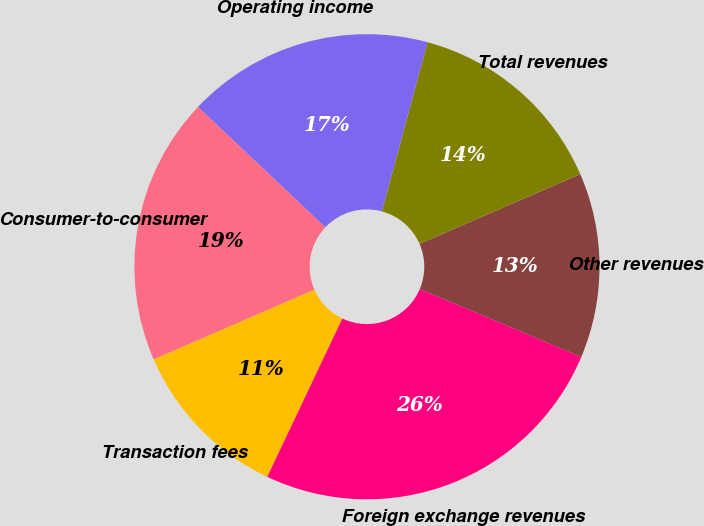Convert chart. <chart><loc_0><loc_0><loc_500><loc_500><pie_chart><fcel>Transaction fees<fcel>Foreign exchange revenues<fcel>Other revenues<fcel>Total revenues<fcel>Operating income<fcel>Consumer-to-consumer<nl><fcel>11.43%<fcel>25.71%<fcel>12.86%<fcel>14.29%<fcel>17.14%<fcel>18.57%<nl></chart> 